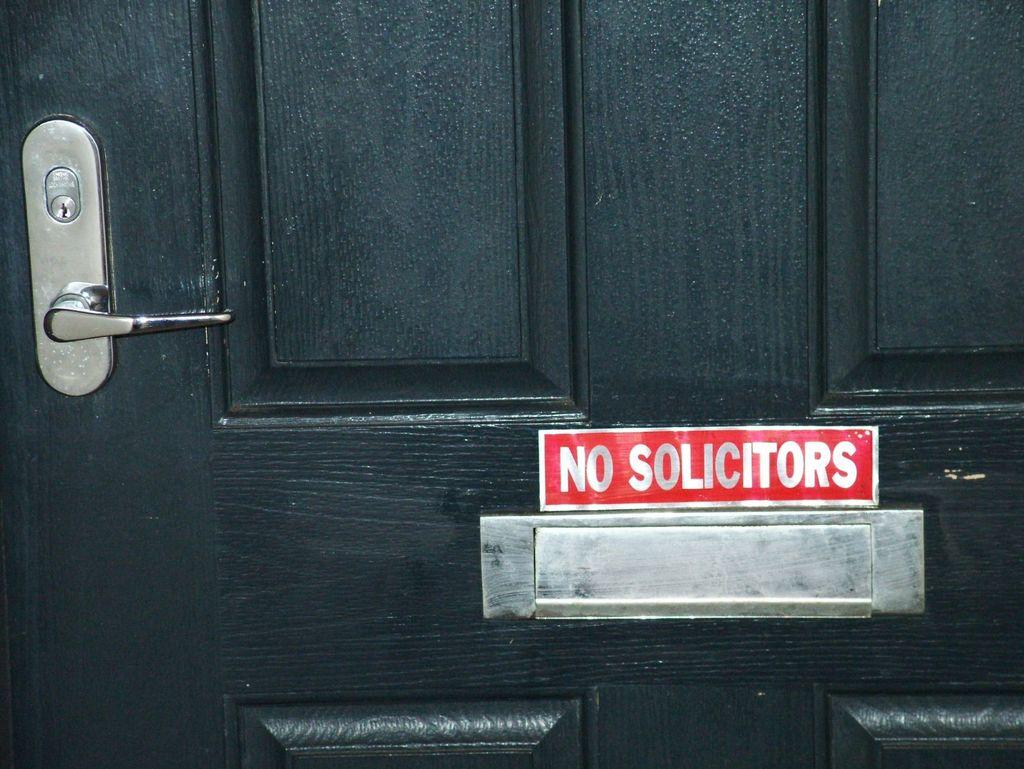What is present in the image that can be used for entering or exiting a space? There is a door in the image that can be used for entering or exiting a space. What feature is present on the door to facilitate its use? The door has a handle. What is the color of the door in the image? The door is black in color. What is attached to the door in the image? There is a board on the door. What grade does the crook receive on his report card in the image? There is no crook or report card present in the image. Is there an umbrella visible in the image? No, there is no umbrella present in the image. 